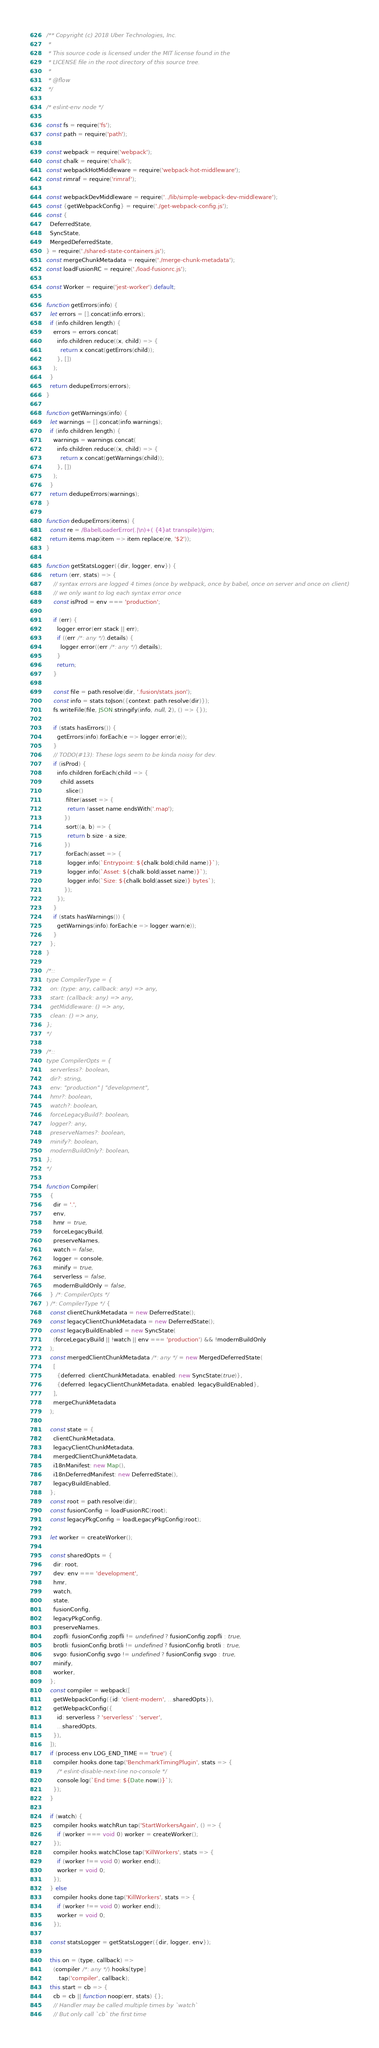Convert code to text. <code><loc_0><loc_0><loc_500><loc_500><_JavaScript_>/** Copyright (c) 2018 Uber Technologies, Inc.
 *
 * This source code is licensed under the MIT license found in the
 * LICENSE file in the root directory of this source tree.
 *
 * @flow
 */

/* eslint-env node */

const fs = require('fs');
const path = require('path');

const webpack = require('webpack');
const chalk = require('chalk');
const webpackHotMiddleware = require('webpack-hot-middleware');
const rimraf = require('rimraf');

const webpackDevMiddleware = require('../lib/simple-webpack-dev-middleware');
const {getWebpackConfig} = require('./get-webpack-config.js');
const {
  DeferredState,
  SyncState,
  MergedDeferredState,
} = require('./shared-state-containers.js');
const mergeChunkMetadata = require('./merge-chunk-metadata');
const loadFusionRC = require('./load-fusionrc.js');

const Worker = require('jest-worker').default;

function getErrors(info) {
  let errors = [].concat(info.errors);
  if (info.children.length) {
    errors = errors.concat(
      info.children.reduce((x, child) => {
        return x.concat(getErrors(child));
      }, [])
    );
  }
  return dedupeErrors(errors);
}

function getWarnings(info) {
  let warnings = [].concat(info.warnings);
  if (info.children.length) {
    warnings = warnings.concat(
      info.children.reduce((x, child) => {
        return x.concat(getWarnings(child));
      }, [])
    );
  }
  return dedupeErrors(warnings);
}

function dedupeErrors(items) {
  const re = /BabelLoaderError(.|\n)+( {4}at transpile)/gim;
  return items.map(item => item.replace(re, '$2'));
}

function getStatsLogger({dir, logger, env}) {
  return (err, stats) => {
    // syntax errors are logged 4 times (once by webpack, once by babel, once on server and once on client)
    // we only want to log each syntax error once
    const isProd = env === 'production';

    if (err) {
      logger.error(err.stack || err);
      if ((err /*: any */).details) {
        logger.error((err /*: any */).details);
      }
      return;
    }

    const file = path.resolve(dir, '.fusion/stats.json');
    const info = stats.toJson({context: path.resolve(dir)});
    fs.writeFile(file, JSON.stringify(info, null, 2), () => {});

    if (stats.hasErrors()) {
      getErrors(info).forEach(e => logger.error(e));
    }
    // TODO(#13): These logs seem to be kinda noisy for dev.
    if (isProd) {
      info.children.forEach(child => {
        child.assets
          .slice()
          .filter(asset => {
            return !asset.name.endsWith('.map');
          })
          .sort((a, b) => {
            return b.size - a.size;
          })
          .forEach(asset => {
            logger.info(`Entrypoint: ${chalk.bold(child.name)}`);
            logger.info(`Asset: ${chalk.bold(asset.name)}`);
            logger.info(`Size: ${chalk.bold(asset.size)} bytes`);
          });
      });
    }
    if (stats.hasWarnings()) {
      getWarnings(info).forEach(e => logger.warn(e));
    }
  };
}

/*::
type CompilerType = {
  on: (type: any, callback: any) => any,
  start: (callback: any) => any,
  getMiddleware: () => any,
  clean: () => any,
};
*/

/*::
type CompilerOpts = {
  serverless?: boolean,
  dir?: string,
  env: "production" | "development",
  hmr?: boolean,
  watch?: boolean,
  forceLegacyBuild?: boolean,
  logger?: any,
  preserveNames?: boolean,
  minify?: boolean,
  modernBuildOnly?: boolean,
};
*/

function Compiler(
  {
    dir = '.',
    env,
    hmr = true,
    forceLegacyBuild,
    preserveNames,
    watch = false,
    logger = console,
    minify = true,
    serverless = false,
    modernBuildOnly = false,
  } /*: CompilerOpts */
) /*: CompilerType */ {
  const clientChunkMetadata = new DeferredState();
  const legacyClientChunkMetadata = new DeferredState();
  const legacyBuildEnabled = new SyncState(
    (forceLegacyBuild || !watch || env === 'production') && !modernBuildOnly
  );
  const mergedClientChunkMetadata /*: any */ = new MergedDeferredState(
    [
      {deferred: clientChunkMetadata, enabled: new SyncState(true)},
      {deferred: legacyClientChunkMetadata, enabled: legacyBuildEnabled},
    ],
    mergeChunkMetadata
  );

  const state = {
    clientChunkMetadata,
    legacyClientChunkMetadata,
    mergedClientChunkMetadata,
    i18nManifest: new Map(),
    i18nDeferredManifest: new DeferredState(),
    legacyBuildEnabled,
  };
  const root = path.resolve(dir);
  const fusionConfig = loadFusionRC(root);
  const legacyPkgConfig = loadLegacyPkgConfig(root);

  let worker = createWorker();

  const sharedOpts = {
    dir: root,
    dev: env === 'development',
    hmr,
    watch,
    state,
    fusionConfig,
    legacyPkgConfig,
    preserveNames,
    zopfli: fusionConfig.zopfli != undefined ? fusionConfig.zopfli : true,
    brotli: fusionConfig.brotli != undefined ? fusionConfig.brotli : true,
    svgo: fusionConfig.svgo != undefined ? fusionConfig.svgo : true,
    minify,
    worker,
  };
  const compiler = webpack([
    getWebpackConfig({id: 'client-modern', ...sharedOpts}),
    getWebpackConfig({
      id: serverless ? 'serverless' : 'server',
      ...sharedOpts,
    }),
  ]);
  if (process.env.LOG_END_TIME == 'true') {
    compiler.hooks.done.tap('BenchmarkTimingPlugin', stats => {
      /* eslint-disable-next-line no-console */
      console.log(`End time: ${Date.now()}`);
    });
  }

  if (watch) {
    compiler.hooks.watchRun.tap('StartWorkersAgain', () => {
      if (worker === void 0) worker = createWorker();
    });
    compiler.hooks.watchClose.tap('KillWorkers', stats => {
      if (worker !== void 0) worker.end();
      worker = void 0;
    });
  } else
    compiler.hooks.done.tap('KillWorkers', stats => {
      if (worker !== void 0) worker.end();
      worker = void 0;
    });

  const statsLogger = getStatsLogger({dir, logger, env});

  this.on = (type, callback) =>
    (compiler /*: any */).hooks[type]
      .tap('compiler', callback);
  this.start = cb => {
    cb = cb || function noop(err, stats) {};
    // Handler may be called multiple times by `watch`
    // But only call `cb` the first time</code> 